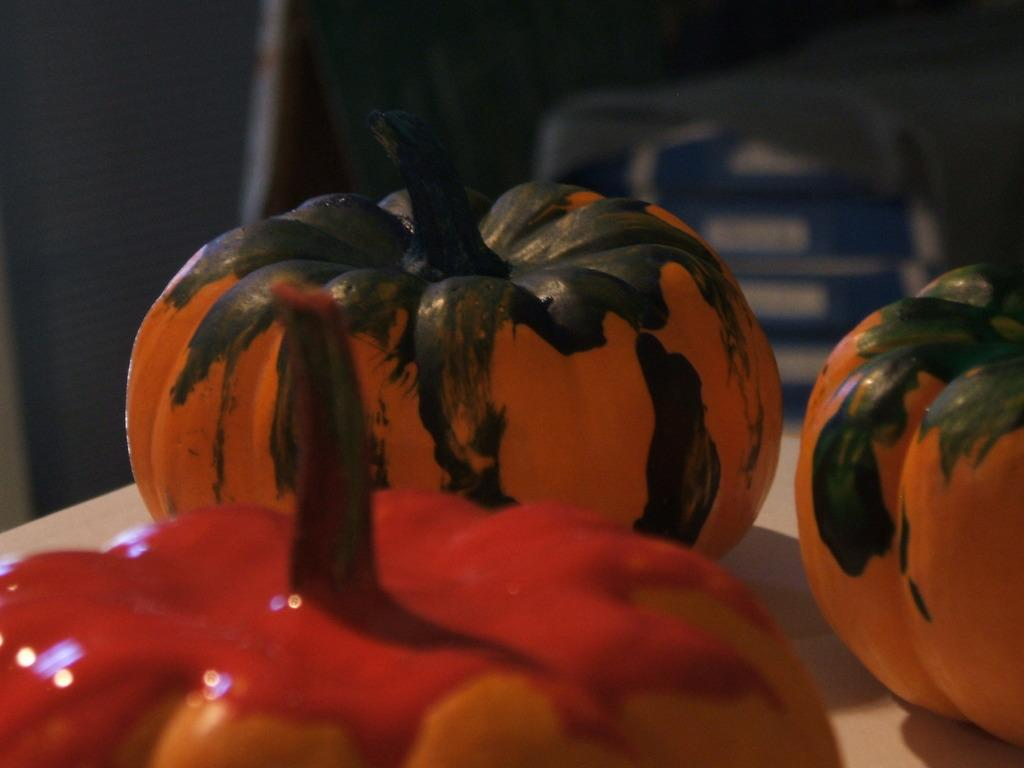What objects are on the table in the image? There are pumpkins on the table. Can you describe the background of the image? The background of the image is blurry. What type of frame is visible around the pumpkins in the image? There is no frame visible around the pumpkins in the image. How many circles can be seen in the image? There are no circles present in the image. 